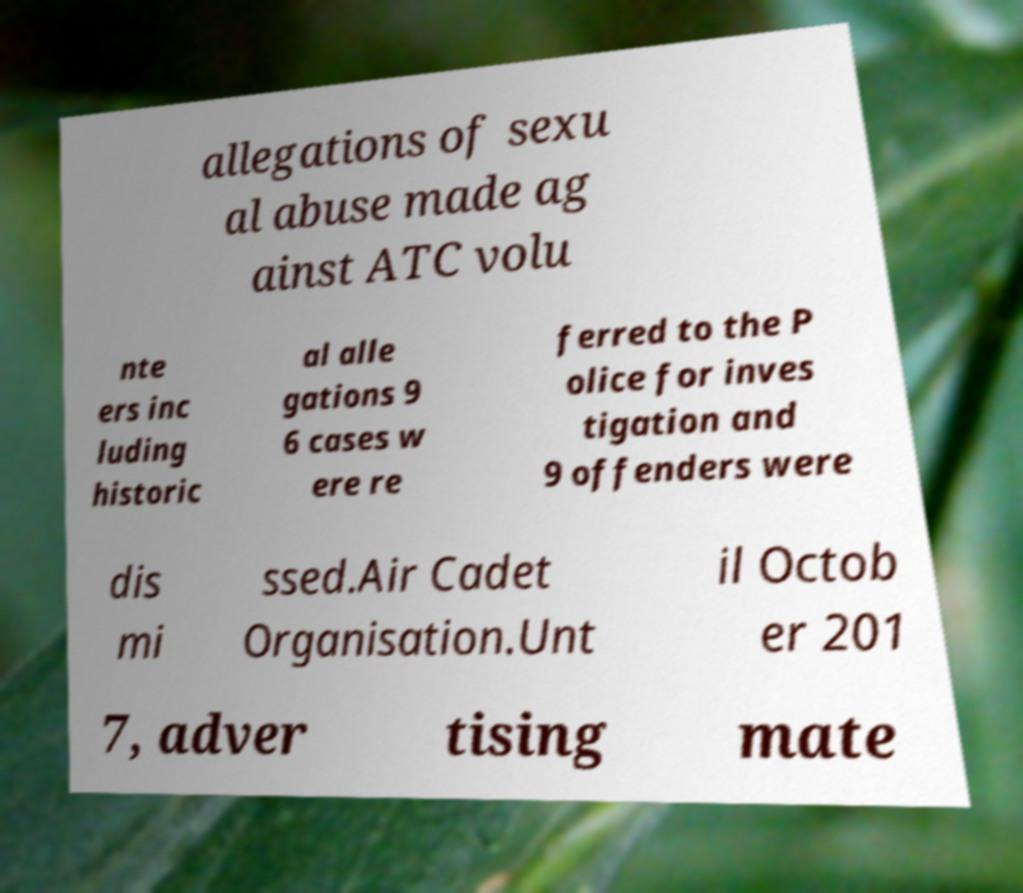There's text embedded in this image that I need extracted. Can you transcribe it verbatim? allegations of sexu al abuse made ag ainst ATC volu nte ers inc luding historic al alle gations 9 6 cases w ere re ferred to the P olice for inves tigation and 9 offenders were dis mi ssed.Air Cadet Organisation.Unt il Octob er 201 7, adver tising mate 